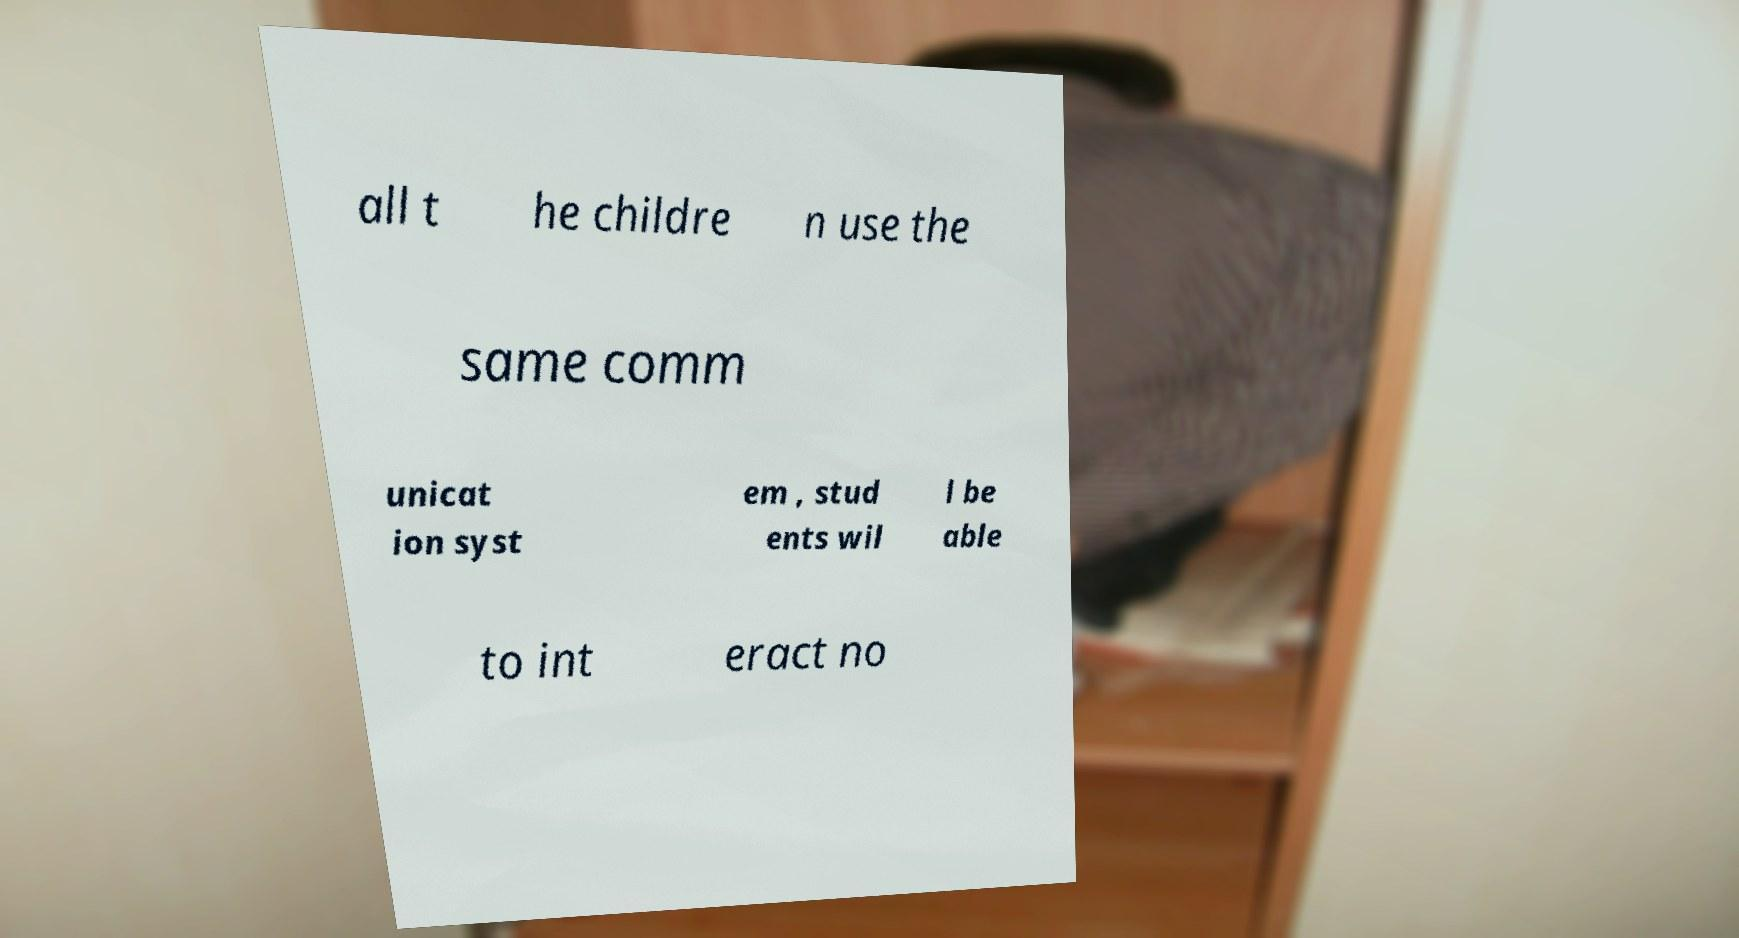What messages or text are displayed in this image? I need them in a readable, typed format. all t he childre n use the same comm unicat ion syst em , stud ents wil l be able to int eract no 